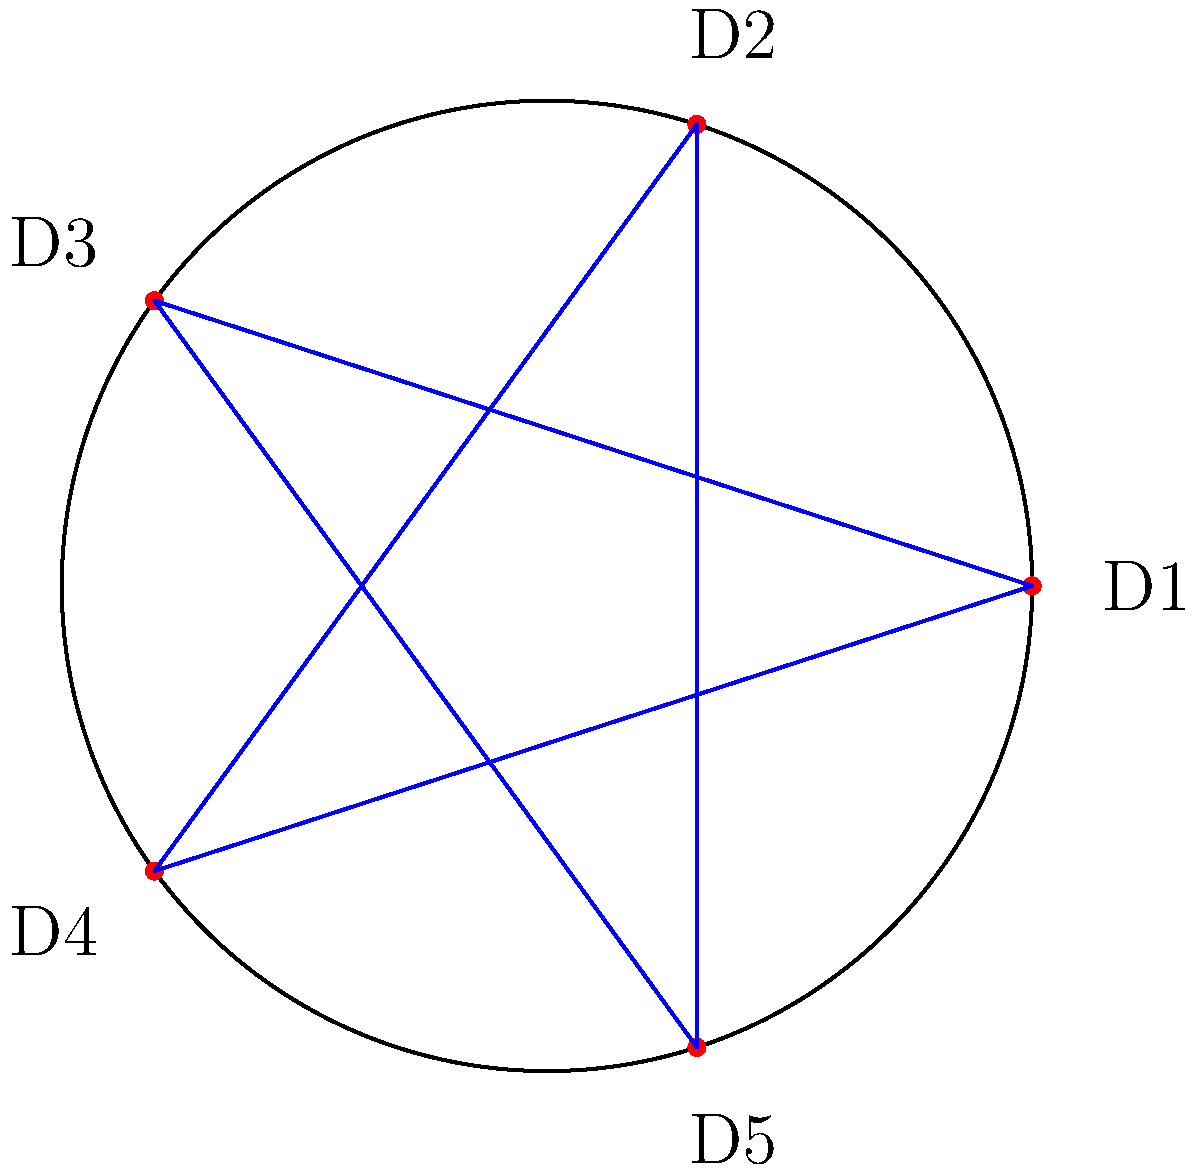At a wedding reception, you're arranging 5 traditional dishes (D1, D2, D3, D4, D5) on a circular buffet table. To maximize guest access, you want to connect dishes that are two positions apart. How many unique connections will you create in this optimal arrangement? Let's approach this step-by-step:

1) We have 5 dishes arranged in a circle, labeled D1 to D5.

2) The optimal arrangement connects each dish to the dish two positions away in both clockwise and counterclockwise directions.

3) Let's list out these connections:
   - D1 connects to D3 and D4
   - D2 connects to D4 and D5
   - D3 connects to D5 and D1
   - D4 connects to D1 and D2
   - D5 connects to D2 and D3

4) Now, let's count the unique connections:
   D1-D3, D1-D4, D2-D4, D2-D5, D3-D5

5) We can see that each connection is counted only once, even though it connects two dishes in both directions.

6) Counting these unique connections, we get 5 in total.

7) This arrangement forms a pentagon, where each vertex (dish) is connected to two non-adjacent vertices.

Therefore, in this optimal arrangement, you will create 5 unique connections between the dishes.
Answer: 5 unique connections 